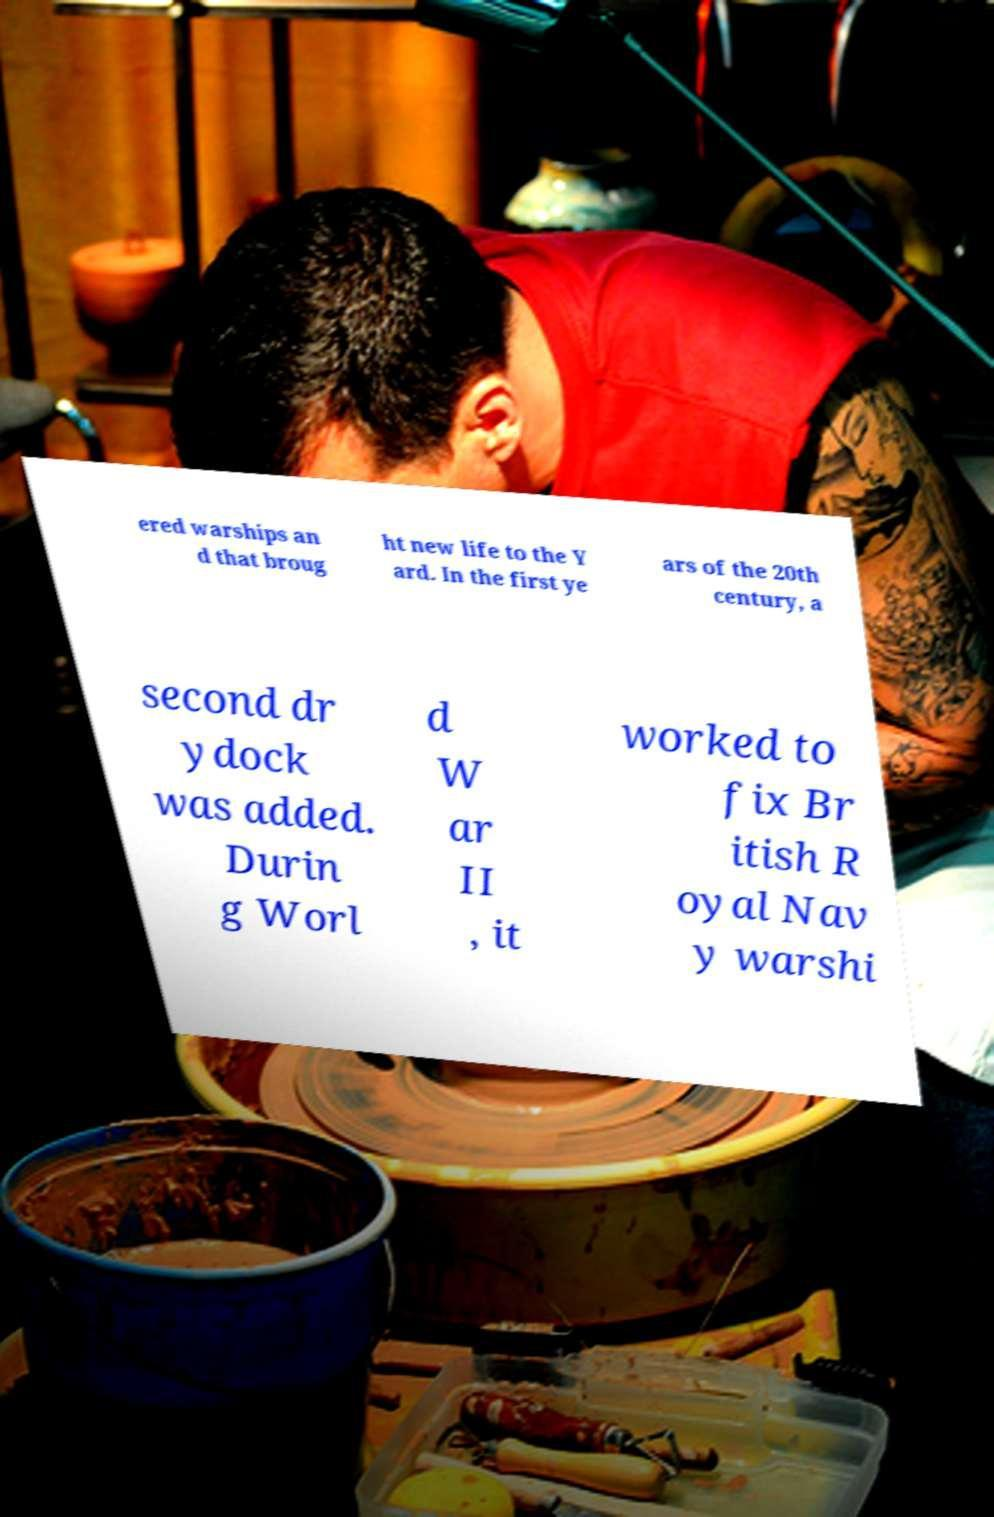Please identify and transcribe the text found in this image. ered warships an d that broug ht new life to the Y ard. In the first ye ars of the 20th century, a second dr ydock was added. Durin g Worl d W ar II , it worked to fix Br itish R oyal Nav y warshi 